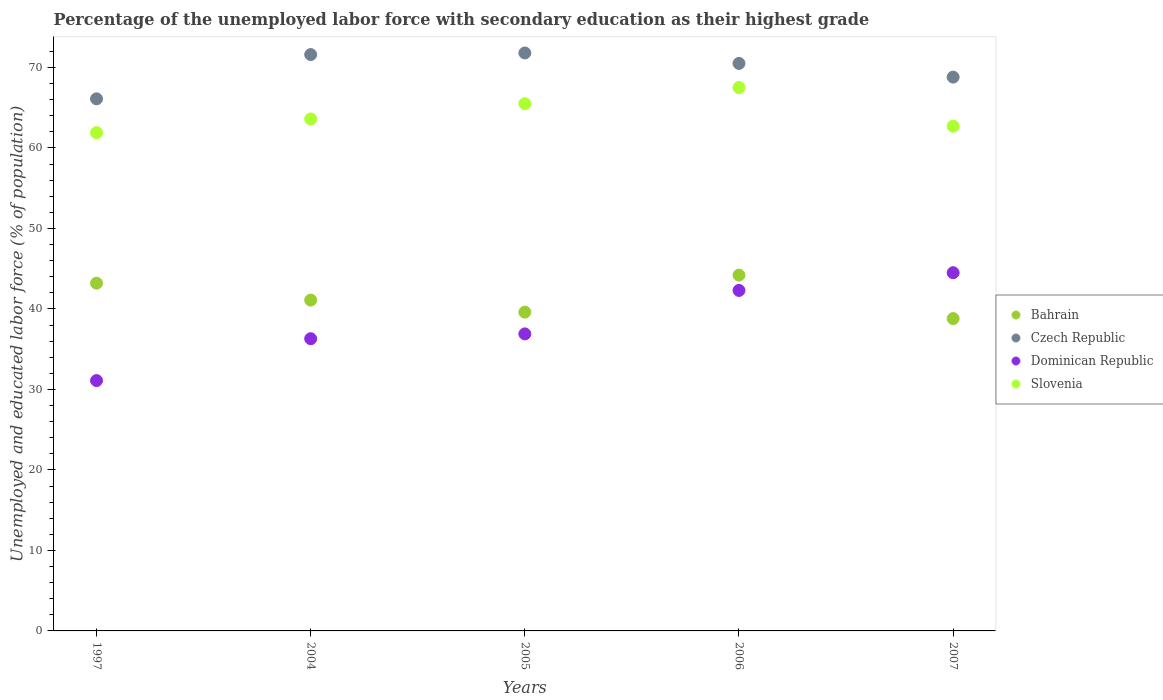How many different coloured dotlines are there?
Your answer should be compact. 4. What is the percentage of the unemployed labor force with secondary education in Slovenia in 2004?
Ensure brevity in your answer.  63.6. Across all years, what is the maximum percentage of the unemployed labor force with secondary education in Slovenia?
Your answer should be compact. 67.5. Across all years, what is the minimum percentage of the unemployed labor force with secondary education in Bahrain?
Your response must be concise. 38.8. What is the total percentage of the unemployed labor force with secondary education in Bahrain in the graph?
Offer a very short reply. 206.9. What is the difference between the percentage of the unemployed labor force with secondary education in Bahrain in 1997 and that in 2004?
Give a very brief answer. 2.1. What is the difference between the percentage of the unemployed labor force with secondary education in Bahrain in 2004 and the percentage of the unemployed labor force with secondary education in Slovenia in 2005?
Your answer should be compact. -24.4. What is the average percentage of the unemployed labor force with secondary education in Czech Republic per year?
Make the answer very short. 69.76. In the year 2007, what is the difference between the percentage of the unemployed labor force with secondary education in Bahrain and percentage of the unemployed labor force with secondary education in Dominican Republic?
Ensure brevity in your answer.  -5.7. What is the ratio of the percentage of the unemployed labor force with secondary education in Czech Republic in 2006 to that in 2007?
Offer a terse response. 1.02. Is the difference between the percentage of the unemployed labor force with secondary education in Bahrain in 1997 and 2007 greater than the difference between the percentage of the unemployed labor force with secondary education in Dominican Republic in 1997 and 2007?
Give a very brief answer. Yes. What is the difference between the highest and the lowest percentage of the unemployed labor force with secondary education in Czech Republic?
Your answer should be very brief. 5.7. In how many years, is the percentage of the unemployed labor force with secondary education in Czech Republic greater than the average percentage of the unemployed labor force with secondary education in Czech Republic taken over all years?
Your answer should be very brief. 3. Is it the case that in every year, the sum of the percentage of the unemployed labor force with secondary education in Dominican Republic and percentage of the unemployed labor force with secondary education in Czech Republic  is greater than the sum of percentage of the unemployed labor force with secondary education in Slovenia and percentage of the unemployed labor force with secondary education in Bahrain?
Provide a short and direct response. Yes. Is it the case that in every year, the sum of the percentage of the unemployed labor force with secondary education in Slovenia and percentage of the unemployed labor force with secondary education in Dominican Republic  is greater than the percentage of the unemployed labor force with secondary education in Czech Republic?
Your answer should be compact. Yes. Is the percentage of the unemployed labor force with secondary education in Czech Republic strictly greater than the percentage of the unemployed labor force with secondary education in Slovenia over the years?
Your answer should be very brief. Yes. Is the percentage of the unemployed labor force with secondary education in Czech Republic strictly less than the percentage of the unemployed labor force with secondary education in Dominican Republic over the years?
Keep it short and to the point. No. Are the values on the major ticks of Y-axis written in scientific E-notation?
Your answer should be very brief. No. What is the title of the graph?
Your response must be concise. Percentage of the unemployed labor force with secondary education as their highest grade. Does "Upper middle income" appear as one of the legend labels in the graph?
Provide a succinct answer. No. What is the label or title of the X-axis?
Offer a terse response. Years. What is the label or title of the Y-axis?
Ensure brevity in your answer.  Unemployed and educated labor force (% of population). What is the Unemployed and educated labor force (% of population) in Bahrain in 1997?
Ensure brevity in your answer.  43.2. What is the Unemployed and educated labor force (% of population) in Czech Republic in 1997?
Offer a terse response. 66.1. What is the Unemployed and educated labor force (% of population) of Dominican Republic in 1997?
Offer a terse response. 31.1. What is the Unemployed and educated labor force (% of population) in Slovenia in 1997?
Provide a short and direct response. 61.9. What is the Unemployed and educated labor force (% of population) in Bahrain in 2004?
Provide a succinct answer. 41.1. What is the Unemployed and educated labor force (% of population) in Czech Republic in 2004?
Provide a succinct answer. 71.6. What is the Unemployed and educated labor force (% of population) of Dominican Republic in 2004?
Provide a short and direct response. 36.3. What is the Unemployed and educated labor force (% of population) in Slovenia in 2004?
Ensure brevity in your answer.  63.6. What is the Unemployed and educated labor force (% of population) of Bahrain in 2005?
Offer a terse response. 39.6. What is the Unemployed and educated labor force (% of population) in Czech Republic in 2005?
Offer a very short reply. 71.8. What is the Unemployed and educated labor force (% of population) in Dominican Republic in 2005?
Your response must be concise. 36.9. What is the Unemployed and educated labor force (% of population) in Slovenia in 2005?
Make the answer very short. 65.5. What is the Unemployed and educated labor force (% of population) of Bahrain in 2006?
Give a very brief answer. 44.2. What is the Unemployed and educated labor force (% of population) of Czech Republic in 2006?
Give a very brief answer. 70.5. What is the Unemployed and educated labor force (% of population) of Dominican Republic in 2006?
Make the answer very short. 42.3. What is the Unemployed and educated labor force (% of population) of Slovenia in 2006?
Ensure brevity in your answer.  67.5. What is the Unemployed and educated labor force (% of population) in Bahrain in 2007?
Provide a succinct answer. 38.8. What is the Unemployed and educated labor force (% of population) in Czech Republic in 2007?
Provide a short and direct response. 68.8. What is the Unemployed and educated labor force (% of population) in Dominican Republic in 2007?
Offer a very short reply. 44.5. What is the Unemployed and educated labor force (% of population) of Slovenia in 2007?
Offer a very short reply. 62.7. Across all years, what is the maximum Unemployed and educated labor force (% of population) in Bahrain?
Provide a short and direct response. 44.2. Across all years, what is the maximum Unemployed and educated labor force (% of population) in Czech Republic?
Ensure brevity in your answer.  71.8. Across all years, what is the maximum Unemployed and educated labor force (% of population) of Dominican Republic?
Offer a terse response. 44.5. Across all years, what is the maximum Unemployed and educated labor force (% of population) in Slovenia?
Your answer should be compact. 67.5. Across all years, what is the minimum Unemployed and educated labor force (% of population) of Bahrain?
Offer a terse response. 38.8. Across all years, what is the minimum Unemployed and educated labor force (% of population) of Czech Republic?
Give a very brief answer. 66.1. Across all years, what is the minimum Unemployed and educated labor force (% of population) of Dominican Republic?
Keep it short and to the point. 31.1. Across all years, what is the minimum Unemployed and educated labor force (% of population) in Slovenia?
Offer a very short reply. 61.9. What is the total Unemployed and educated labor force (% of population) of Bahrain in the graph?
Keep it short and to the point. 206.9. What is the total Unemployed and educated labor force (% of population) in Czech Republic in the graph?
Provide a succinct answer. 348.8. What is the total Unemployed and educated labor force (% of population) of Dominican Republic in the graph?
Make the answer very short. 191.1. What is the total Unemployed and educated labor force (% of population) in Slovenia in the graph?
Provide a succinct answer. 321.2. What is the difference between the Unemployed and educated labor force (% of population) in Bahrain in 1997 and that in 2004?
Make the answer very short. 2.1. What is the difference between the Unemployed and educated labor force (% of population) in Czech Republic in 1997 and that in 2004?
Provide a short and direct response. -5.5. What is the difference between the Unemployed and educated labor force (% of population) of Dominican Republic in 1997 and that in 2004?
Offer a very short reply. -5.2. What is the difference between the Unemployed and educated labor force (% of population) of Slovenia in 1997 and that in 2004?
Your response must be concise. -1.7. What is the difference between the Unemployed and educated labor force (% of population) of Czech Republic in 1997 and that in 2005?
Your response must be concise. -5.7. What is the difference between the Unemployed and educated labor force (% of population) in Slovenia in 1997 and that in 2005?
Keep it short and to the point. -3.6. What is the difference between the Unemployed and educated labor force (% of population) in Czech Republic in 1997 and that in 2006?
Offer a terse response. -4.4. What is the difference between the Unemployed and educated labor force (% of population) in Bahrain in 2004 and that in 2006?
Offer a very short reply. -3.1. What is the difference between the Unemployed and educated labor force (% of population) in Czech Republic in 2004 and that in 2006?
Ensure brevity in your answer.  1.1. What is the difference between the Unemployed and educated labor force (% of population) in Dominican Republic in 2004 and that in 2006?
Your answer should be very brief. -6. What is the difference between the Unemployed and educated labor force (% of population) of Slovenia in 2004 and that in 2006?
Ensure brevity in your answer.  -3.9. What is the difference between the Unemployed and educated labor force (% of population) of Bahrain in 2004 and that in 2007?
Your answer should be very brief. 2.3. What is the difference between the Unemployed and educated labor force (% of population) of Czech Republic in 2004 and that in 2007?
Make the answer very short. 2.8. What is the difference between the Unemployed and educated labor force (% of population) in Dominican Republic in 2004 and that in 2007?
Your response must be concise. -8.2. What is the difference between the Unemployed and educated labor force (% of population) in Slovenia in 2004 and that in 2007?
Provide a short and direct response. 0.9. What is the difference between the Unemployed and educated labor force (% of population) of Czech Republic in 2005 and that in 2006?
Offer a terse response. 1.3. What is the difference between the Unemployed and educated labor force (% of population) of Slovenia in 2005 and that in 2006?
Provide a succinct answer. -2. What is the difference between the Unemployed and educated labor force (% of population) of Czech Republic in 2005 and that in 2007?
Make the answer very short. 3. What is the difference between the Unemployed and educated labor force (% of population) of Slovenia in 2005 and that in 2007?
Make the answer very short. 2.8. What is the difference between the Unemployed and educated labor force (% of population) in Bahrain in 2006 and that in 2007?
Keep it short and to the point. 5.4. What is the difference between the Unemployed and educated labor force (% of population) in Czech Republic in 2006 and that in 2007?
Give a very brief answer. 1.7. What is the difference between the Unemployed and educated labor force (% of population) of Dominican Republic in 2006 and that in 2007?
Give a very brief answer. -2.2. What is the difference between the Unemployed and educated labor force (% of population) in Bahrain in 1997 and the Unemployed and educated labor force (% of population) in Czech Republic in 2004?
Give a very brief answer. -28.4. What is the difference between the Unemployed and educated labor force (% of population) in Bahrain in 1997 and the Unemployed and educated labor force (% of population) in Dominican Republic in 2004?
Offer a terse response. 6.9. What is the difference between the Unemployed and educated labor force (% of population) of Bahrain in 1997 and the Unemployed and educated labor force (% of population) of Slovenia in 2004?
Provide a short and direct response. -20.4. What is the difference between the Unemployed and educated labor force (% of population) of Czech Republic in 1997 and the Unemployed and educated labor force (% of population) of Dominican Republic in 2004?
Make the answer very short. 29.8. What is the difference between the Unemployed and educated labor force (% of population) in Czech Republic in 1997 and the Unemployed and educated labor force (% of population) in Slovenia in 2004?
Provide a succinct answer. 2.5. What is the difference between the Unemployed and educated labor force (% of population) in Dominican Republic in 1997 and the Unemployed and educated labor force (% of population) in Slovenia in 2004?
Your answer should be very brief. -32.5. What is the difference between the Unemployed and educated labor force (% of population) of Bahrain in 1997 and the Unemployed and educated labor force (% of population) of Czech Republic in 2005?
Offer a terse response. -28.6. What is the difference between the Unemployed and educated labor force (% of population) in Bahrain in 1997 and the Unemployed and educated labor force (% of population) in Dominican Republic in 2005?
Provide a succinct answer. 6.3. What is the difference between the Unemployed and educated labor force (% of population) in Bahrain in 1997 and the Unemployed and educated labor force (% of population) in Slovenia in 2005?
Offer a terse response. -22.3. What is the difference between the Unemployed and educated labor force (% of population) in Czech Republic in 1997 and the Unemployed and educated labor force (% of population) in Dominican Republic in 2005?
Keep it short and to the point. 29.2. What is the difference between the Unemployed and educated labor force (% of population) in Dominican Republic in 1997 and the Unemployed and educated labor force (% of population) in Slovenia in 2005?
Ensure brevity in your answer.  -34.4. What is the difference between the Unemployed and educated labor force (% of population) of Bahrain in 1997 and the Unemployed and educated labor force (% of population) of Czech Republic in 2006?
Your answer should be compact. -27.3. What is the difference between the Unemployed and educated labor force (% of population) in Bahrain in 1997 and the Unemployed and educated labor force (% of population) in Dominican Republic in 2006?
Your response must be concise. 0.9. What is the difference between the Unemployed and educated labor force (% of population) of Bahrain in 1997 and the Unemployed and educated labor force (% of population) of Slovenia in 2006?
Offer a very short reply. -24.3. What is the difference between the Unemployed and educated labor force (% of population) in Czech Republic in 1997 and the Unemployed and educated labor force (% of population) in Dominican Republic in 2006?
Your answer should be very brief. 23.8. What is the difference between the Unemployed and educated labor force (% of population) in Czech Republic in 1997 and the Unemployed and educated labor force (% of population) in Slovenia in 2006?
Offer a very short reply. -1.4. What is the difference between the Unemployed and educated labor force (% of population) in Dominican Republic in 1997 and the Unemployed and educated labor force (% of population) in Slovenia in 2006?
Give a very brief answer. -36.4. What is the difference between the Unemployed and educated labor force (% of population) of Bahrain in 1997 and the Unemployed and educated labor force (% of population) of Czech Republic in 2007?
Offer a very short reply. -25.6. What is the difference between the Unemployed and educated labor force (% of population) in Bahrain in 1997 and the Unemployed and educated labor force (% of population) in Slovenia in 2007?
Your answer should be compact. -19.5. What is the difference between the Unemployed and educated labor force (% of population) in Czech Republic in 1997 and the Unemployed and educated labor force (% of population) in Dominican Republic in 2007?
Provide a succinct answer. 21.6. What is the difference between the Unemployed and educated labor force (% of population) in Dominican Republic in 1997 and the Unemployed and educated labor force (% of population) in Slovenia in 2007?
Provide a short and direct response. -31.6. What is the difference between the Unemployed and educated labor force (% of population) in Bahrain in 2004 and the Unemployed and educated labor force (% of population) in Czech Republic in 2005?
Your answer should be compact. -30.7. What is the difference between the Unemployed and educated labor force (% of population) of Bahrain in 2004 and the Unemployed and educated labor force (% of population) of Slovenia in 2005?
Your answer should be compact. -24.4. What is the difference between the Unemployed and educated labor force (% of population) of Czech Republic in 2004 and the Unemployed and educated labor force (% of population) of Dominican Republic in 2005?
Keep it short and to the point. 34.7. What is the difference between the Unemployed and educated labor force (% of population) in Czech Republic in 2004 and the Unemployed and educated labor force (% of population) in Slovenia in 2005?
Offer a terse response. 6.1. What is the difference between the Unemployed and educated labor force (% of population) of Dominican Republic in 2004 and the Unemployed and educated labor force (% of population) of Slovenia in 2005?
Provide a short and direct response. -29.2. What is the difference between the Unemployed and educated labor force (% of population) in Bahrain in 2004 and the Unemployed and educated labor force (% of population) in Czech Republic in 2006?
Provide a short and direct response. -29.4. What is the difference between the Unemployed and educated labor force (% of population) in Bahrain in 2004 and the Unemployed and educated labor force (% of population) in Dominican Republic in 2006?
Provide a short and direct response. -1.2. What is the difference between the Unemployed and educated labor force (% of population) in Bahrain in 2004 and the Unemployed and educated labor force (% of population) in Slovenia in 2006?
Offer a very short reply. -26.4. What is the difference between the Unemployed and educated labor force (% of population) in Czech Republic in 2004 and the Unemployed and educated labor force (% of population) in Dominican Republic in 2006?
Your response must be concise. 29.3. What is the difference between the Unemployed and educated labor force (% of population) in Dominican Republic in 2004 and the Unemployed and educated labor force (% of population) in Slovenia in 2006?
Provide a short and direct response. -31.2. What is the difference between the Unemployed and educated labor force (% of population) of Bahrain in 2004 and the Unemployed and educated labor force (% of population) of Czech Republic in 2007?
Make the answer very short. -27.7. What is the difference between the Unemployed and educated labor force (% of population) in Bahrain in 2004 and the Unemployed and educated labor force (% of population) in Dominican Republic in 2007?
Ensure brevity in your answer.  -3.4. What is the difference between the Unemployed and educated labor force (% of population) of Bahrain in 2004 and the Unemployed and educated labor force (% of population) of Slovenia in 2007?
Ensure brevity in your answer.  -21.6. What is the difference between the Unemployed and educated labor force (% of population) in Czech Republic in 2004 and the Unemployed and educated labor force (% of population) in Dominican Republic in 2007?
Your answer should be compact. 27.1. What is the difference between the Unemployed and educated labor force (% of population) of Czech Republic in 2004 and the Unemployed and educated labor force (% of population) of Slovenia in 2007?
Offer a very short reply. 8.9. What is the difference between the Unemployed and educated labor force (% of population) in Dominican Republic in 2004 and the Unemployed and educated labor force (% of population) in Slovenia in 2007?
Ensure brevity in your answer.  -26.4. What is the difference between the Unemployed and educated labor force (% of population) in Bahrain in 2005 and the Unemployed and educated labor force (% of population) in Czech Republic in 2006?
Ensure brevity in your answer.  -30.9. What is the difference between the Unemployed and educated labor force (% of population) in Bahrain in 2005 and the Unemployed and educated labor force (% of population) in Dominican Republic in 2006?
Make the answer very short. -2.7. What is the difference between the Unemployed and educated labor force (% of population) in Bahrain in 2005 and the Unemployed and educated labor force (% of population) in Slovenia in 2006?
Ensure brevity in your answer.  -27.9. What is the difference between the Unemployed and educated labor force (% of population) of Czech Republic in 2005 and the Unemployed and educated labor force (% of population) of Dominican Republic in 2006?
Offer a terse response. 29.5. What is the difference between the Unemployed and educated labor force (% of population) of Czech Republic in 2005 and the Unemployed and educated labor force (% of population) of Slovenia in 2006?
Your answer should be very brief. 4.3. What is the difference between the Unemployed and educated labor force (% of population) in Dominican Republic in 2005 and the Unemployed and educated labor force (% of population) in Slovenia in 2006?
Offer a terse response. -30.6. What is the difference between the Unemployed and educated labor force (% of population) in Bahrain in 2005 and the Unemployed and educated labor force (% of population) in Czech Republic in 2007?
Provide a succinct answer. -29.2. What is the difference between the Unemployed and educated labor force (% of population) of Bahrain in 2005 and the Unemployed and educated labor force (% of population) of Slovenia in 2007?
Provide a succinct answer. -23.1. What is the difference between the Unemployed and educated labor force (% of population) of Czech Republic in 2005 and the Unemployed and educated labor force (% of population) of Dominican Republic in 2007?
Your response must be concise. 27.3. What is the difference between the Unemployed and educated labor force (% of population) of Czech Republic in 2005 and the Unemployed and educated labor force (% of population) of Slovenia in 2007?
Offer a very short reply. 9.1. What is the difference between the Unemployed and educated labor force (% of population) in Dominican Republic in 2005 and the Unemployed and educated labor force (% of population) in Slovenia in 2007?
Make the answer very short. -25.8. What is the difference between the Unemployed and educated labor force (% of population) in Bahrain in 2006 and the Unemployed and educated labor force (% of population) in Czech Republic in 2007?
Provide a short and direct response. -24.6. What is the difference between the Unemployed and educated labor force (% of population) in Bahrain in 2006 and the Unemployed and educated labor force (% of population) in Dominican Republic in 2007?
Provide a short and direct response. -0.3. What is the difference between the Unemployed and educated labor force (% of population) in Bahrain in 2006 and the Unemployed and educated labor force (% of population) in Slovenia in 2007?
Give a very brief answer. -18.5. What is the difference between the Unemployed and educated labor force (% of population) in Czech Republic in 2006 and the Unemployed and educated labor force (% of population) in Slovenia in 2007?
Offer a terse response. 7.8. What is the difference between the Unemployed and educated labor force (% of population) of Dominican Republic in 2006 and the Unemployed and educated labor force (% of population) of Slovenia in 2007?
Provide a short and direct response. -20.4. What is the average Unemployed and educated labor force (% of population) in Bahrain per year?
Provide a succinct answer. 41.38. What is the average Unemployed and educated labor force (% of population) in Czech Republic per year?
Your response must be concise. 69.76. What is the average Unemployed and educated labor force (% of population) of Dominican Republic per year?
Your answer should be very brief. 38.22. What is the average Unemployed and educated labor force (% of population) in Slovenia per year?
Your answer should be very brief. 64.24. In the year 1997, what is the difference between the Unemployed and educated labor force (% of population) of Bahrain and Unemployed and educated labor force (% of population) of Czech Republic?
Keep it short and to the point. -22.9. In the year 1997, what is the difference between the Unemployed and educated labor force (% of population) in Bahrain and Unemployed and educated labor force (% of population) in Slovenia?
Your answer should be very brief. -18.7. In the year 1997, what is the difference between the Unemployed and educated labor force (% of population) in Czech Republic and Unemployed and educated labor force (% of population) in Dominican Republic?
Your answer should be very brief. 35. In the year 1997, what is the difference between the Unemployed and educated labor force (% of population) in Dominican Republic and Unemployed and educated labor force (% of population) in Slovenia?
Ensure brevity in your answer.  -30.8. In the year 2004, what is the difference between the Unemployed and educated labor force (% of population) in Bahrain and Unemployed and educated labor force (% of population) in Czech Republic?
Give a very brief answer. -30.5. In the year 2004, what is the difference between the Unemployed and educated labor force (% of population) in Bahrain and Unemployed and educated labor force (% of population) in Slovenia?
Provide a short and direct response. -22.5. In the year 2004, what is the difference between the Unemployed and educated labor force (% of population) in Czech Republic and Unemployed and educated labor force (% of population) in Dominican Republic?
Offer a terse response. 35.3. In the year 2004, what is the difference between the Unemployed and educated labor force (% of population) in Czech Republic and Unemployed and educated labor force (% of population) in Slovenia?
Your answer should be compact. 8. In the year 2004, what is the difference between the Unemployed and educated labor force (% of population) in Dominican Republic and Unemployed and educated labor force (% of population) in Slovenia?
Your answer should be compact. -27.3. In the year 2005, what is the difference between the Unemployed and educated labor force (% of population) in Bahrain and Unemployed and educated labor force (% of population) in Czech Republic?
Ensure brevity in your answer.  -32.2. In the year 2005, what is the difference between the Unemployed and educated labor force (% of population) of Bahrain and Unemployed and educated labor force (% of population) of Dominican Republic?
Provide a short and direct response. 2.7. In the year 2005, what is the difference between the Unemployed and educated labor force (% of population) of Bahrain and Unemployed and educated labor force (% of population) of Slovenia?
Make the answer very short. -25.9. In the year 2005, what is the difference between the Unemployed and educated labor force (% of population) in Czech Republic and Unemployed and educated labor force (% of population) in Dominican Republic?
Keep it short and to the point. 34.9. In the year 2005, what is the difference between the Unemployed and educated labor force (% of population) in Dominican Republic and Unemployed and educated labor force (% of population) in Slovenia?
Provide a succinct answer. -28.6. In the year 2006, what is the difference between the Unemployed and educated labor force (% of population) of Bahrain and Unemployed and educated labor force (% of population) of Czech Republic?
Ensure brevity in your answer.  -26.3. In the year 2006, what is the difference between the Unemployed and educated labor force (% of population) in Bahrain and Unemployed and educated labor force (% of population) in Slovenia?
Your response must be concise. -23.3. In the year 2006, what is the difference between the Unemployed and educated labor force (% of population) in Czech Republic and Unemployed and educated labor force (% of population) in Dominican Republic?
Keep it short and to the point. 28.2. In the year 2006, what is the difference between the Unemployed and educated labor force (% of population) of Dominican Republic and Unemployed and educated labor force (% of population) of Slovenia?
Offer a very short reply. -25.2. In the year 2007, what is the difference between the Unemployed and educated labor force (% of population) of Bahrain and Unemployed and educated labor force (% of population) of Dominican Republic?
Your answer should be very brief. -5.7. In the year 2007, what is the difference between the Unemployed and educated labor force (% of population) in Bahrain and Unemployed and educated labor force (% of population) in Slovenia?
Your answer should be very brief. -23.9. In the year 2007, what is the difference between the Unemployed and educated labor force (% of population) of Czech Republic and Unemployed and educated labor force (% of population) of Dominican Republic?
Offer a terse response. 24.3. In the year 2007, what is the difference between the Unemployed and educated labor force (% of population) of Dominican Republic and Unemployed and educated labor force (% of population) of Slovenia?
Offer a very short reply. -18.2. What is the ratio of the Unemployed and educated labor force (% of population) of Bahrain in 1997 to that in 2004?
Your response must be concise. 1.05. What is the ratio of the Unemployed and educated labor force (% of population) in Czech Republic in 1997 to that in 2004?
Your response must be concise. 0.92. What is the ratio of the Unemployed and educated labor force (% of population) of Dominican Republic in 1997 to that in 2004?
Give a very brief answer. 0.86. What is the ratio of the Unemployed and educated labor force (% of population) in Slovenia in 1997 to that in 2004?
Make the answer very short. 0.97. What is the ratio of the Unemployed and educated labor force (% of population) in Bahrain in 1997 to that in 2005?
Your response must be concise. 1.09. What is the ratio of the Unemployed and educated labor force (% of population) in Czech Republic in 1997 to that in 2005?
Provide a succinct answer. 0.92. What is the ratio of the Unemployed and educated labor force (% of population) of Dominican Republic in 1997 to that in 2005?
Provide a short and direct response. 0.84. What is the ratio of the Unemployed and educated labor force (% of population) of Slovenia in 1997 to that in 2005?
Keep it short and to the point. 0.94. What is the ratio of the Unemployed and educated labor force (% of population) of Bahrain in 1997 to that in 2006?
Provide a succinct answer. 0.98. What is the ratio of the Unemployed and educated labor force (% of population) of Czech Republic in 1997 to that in 2006?
Provide a short and direct response. 0.94. What is the ratio of the Unemployed and educated labor force (% of population) of Dominican Republic in 1997 to that in 2006?
Offer a very short reply. 0.74. What is the ratio of the Unemployed and educated labor force (% of population) in Slovenia in 1997 to that in 2006?
Offer a terse response. 0.92. What is the ratio of the Unemployed and educated labor force (% of population) of Bahrain in 1997 to that in 2007?
Provide a succinct answer. 1.11. What is the ratio of the Unemployed and educated labor force (% of population) of Czech Republic in 1997 to that in 2007?
Offer a terse response. 0.96. What is the ratio of the Unemployed and educated labor force (% of population) of Dominican Republic in 1997 to that in 2007?
Your answer should be compact. 0.7. What is the ratio of the Unemployed and educated labor force (% of population) in Slovenia in 1997 to that in 2007?
Offer a terse response. 0.99. What is the ratio of the Unemployed and educated labor force (% of population) of Bahrain in 2004 to that in 2005?
Provide a succinct answer. 1.04. What is the ratio of the Unemployed and educated labor force (% of population) in Dominican Republic in 2004 to that in 2005?
Give a very brief answer. 0.98. What is the ratio of the Unemployed and educated labor force (% of population) of Bahrain in 2004 to that in 2006?
Offer a very short reply. 0.93. What is the ratio of the Unemployed and educated labor force (% of population) in Czech Republic in 2004 to that in 2006?
Your response must be concise. 1.02. What is the ratio of the Unemployed and educated labor force (% of population) of Dominican Republic in 2004 to that in 2006?
Ensure brevity in your answer.  0.86. What is the ratio of the Unemployed and educated labor force (% of population) of Slovenia in 2004 to that in 2006?
Your answer should be compact. 0.94. What is the ratio of the Unemployed and educated labor force (% of population) of Bahrain in 2004 to that in 2007?
Your response must be concise. 1.06. What is the ratio of the Unemployed and educated labor force (% of population) of Czech Republic in 2004 to that in 2007?
Offer a terse response. 1.04. What is the ratio of the Unemployed and educated labor force (% of population) in Dominican Republic in 2004 to that in 2007?
Offer a terse response. 0.82. What is the ratio of the Unemployed and educated labor force (% of population) in Slovenia in 2004 to that in 2007?
Your response must be concise. 1.01. What is the ratio of the Unemployed and educated labor force (% of population) of Bahrain in 2005 to that in 2006?
Your response must be concise. 0.9. What is the ratio of the Unemployed and educated labor force (% of population) of Czech Republic in 2005 to that in 2006?
Provide a succinct answer. 1.02. What is the ratio of the Unemployed and educated labor force (% of population) of Dominican Republic in 2005 to that in 2006?
Keep it short and to the point. 0.87. What is the ratio of the Unemployed and educated labor force (% of population) in Slovenia in 2005 to that in 2006?
Keep it short and to the point. 0.97. What is the ratio of the Unemployed and educated labor force (% of population) in Bahrain in 2005 to that in 2007?
Your answer should be very brief. 1.02. What is the ratio of the Unemployed and educated labor force (% of population) in Czech Republic in 2005 to that in 2007?
Your answer should be very brief. 1.04. What is the ratio of the Unemployed and educated labor force (% of population) in Dominican Republic in 2005 to that in 2007?
Ensure brevity in your answer.  0.83. What is the ratio of the Unemployed and educated labor force (% of population) in Slovenia in 2005 to that in 2007?
Keep it short and to the point. 1.04. What is the ratio of the Unemployed and educated labor force (% of population) of Bahrain in 2006 to that in 2007?
Make the answer very short. 1.14. What is the ratio of the Unemployed and educated labor force (% of population) of Czech Republic in 2006 to that in 2007?
Give a very brief answer. 1.02. What is the ratio of the Unemployed and educated labor force (% of population) in Dominican Republic in 2006 to that in 2007?
Keep it short and to the point. 0.95. What is the ratio of the Unemployed and educated labor force (% of population) in Slovenia in 2006 to that in 2007?
Make the answer very short. 1.08. What is the difference between the highest and the second highest Unemployed and educated labor force (% of population) in Dominican Republic?
Provide a short and direct response. 2.2. What is the difference between the highest and the lowest Unemployed and educated labor force (% of population) in Dominican Republic?
Make the answer very short. 13.4. What is the difference between the highest and the lowest Unemployed and educated labor force (% of population) in Slovenia?
Offer a terse response. 5.6. 